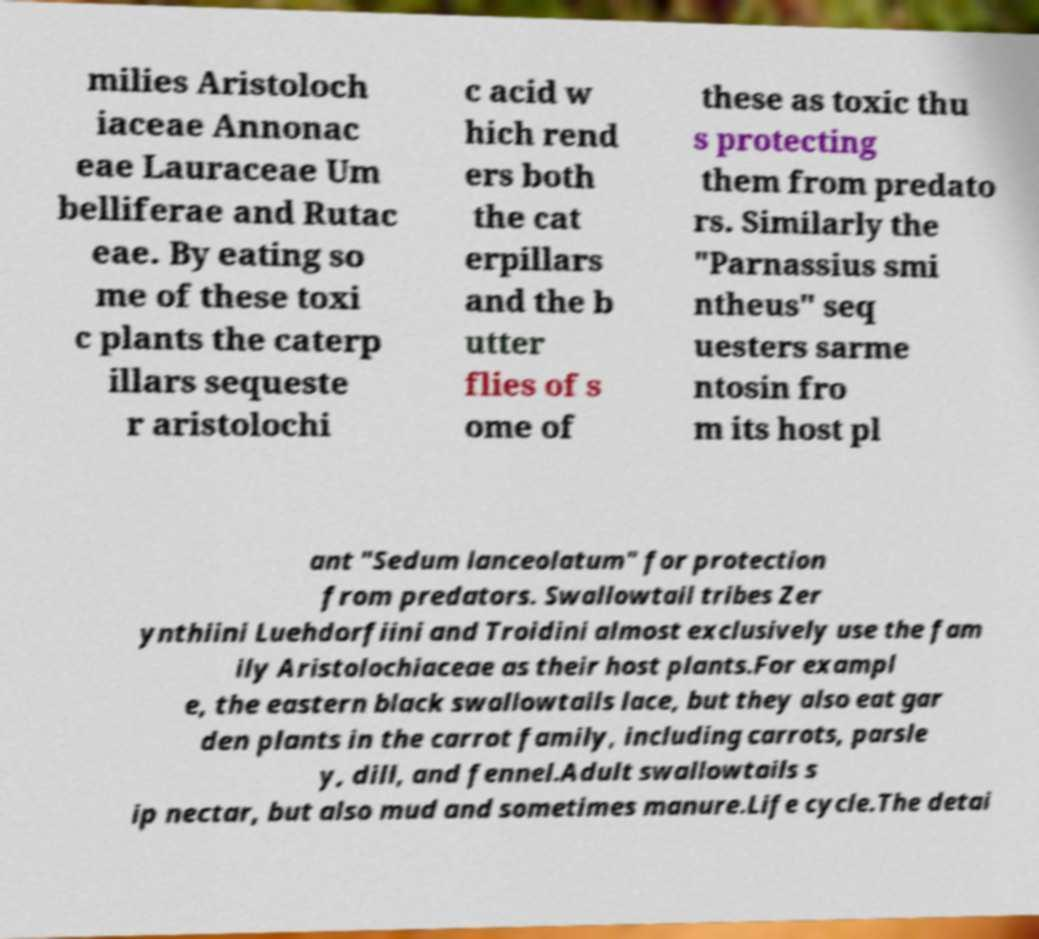Could you extract and type out the text from this image? milies Aristoloch iaceae Annonac eae Lauraceae Um belliferae and Rutac eae. By eating so me of these toxi c plants the caterp illars sequeste r aristolochi c acid w hich rend ers both the cat erpillars and the b utter flies of s ome of these as toxic thu s protecting them from predato rs. Similarly the "Parnassius smi ntheus" seq uesters sarme ntosin fro m its host pl ant "Sedum lanceolatum" for protection from predators. Swallowtail tribes Zer ynthiini Luehdorfiini and Troidini almost exclusively use the fam ily Aristolochiaceae as their host plants.For exampl e, the eastern black swallowtails lace, but they also eat gar den plants in the carrot family, including carrots, parsle y, dill, and fennel.Adult swallowtails s ip nectar, but also mud and sometimes manure.Life cycle.The detai 